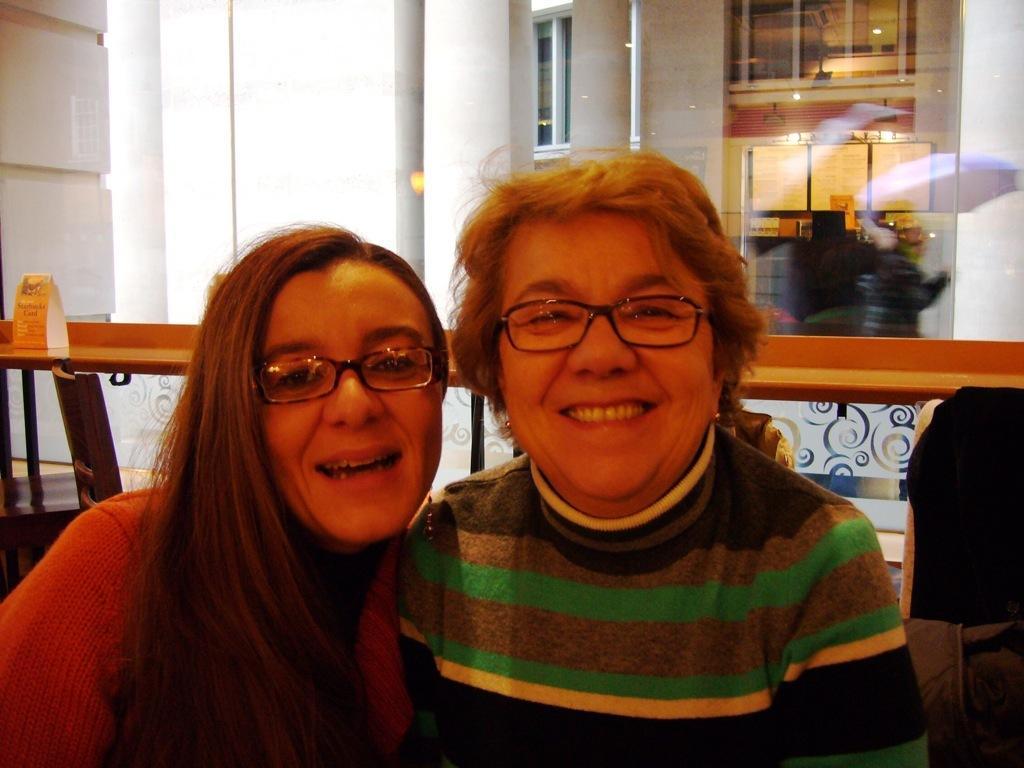Describe this image in one or two sentences. In this image there are two women. They are smiling. Behind them there is a table. There is a board on the table. In the background there are pillars and glass windows to the wall. 